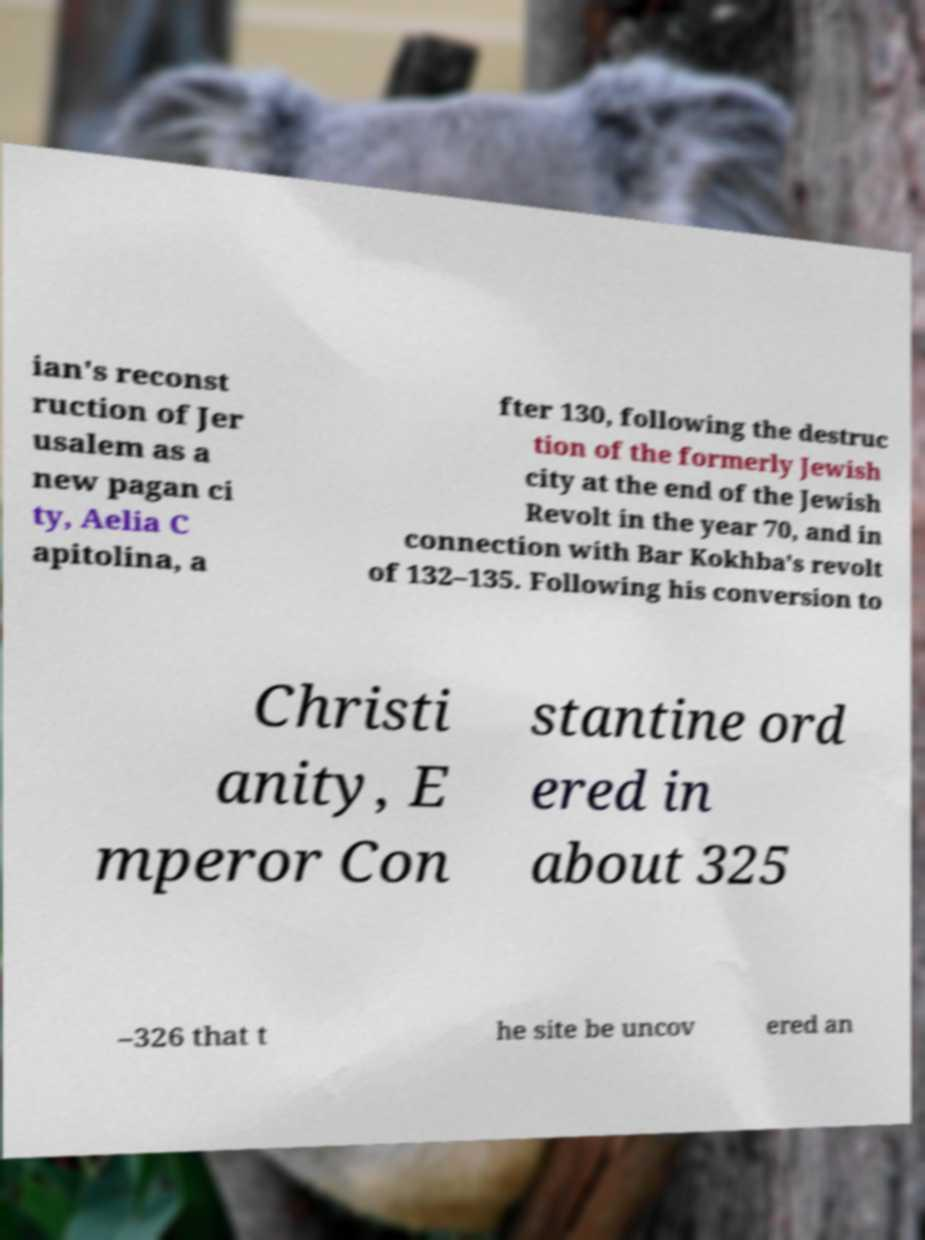Can you accurately transcribe the text from the provided image for me? ian's reconst ruction of Jer usalem as a new pagan ci ty, Aelia C apitolina, a fter 130, following the destruc tion of the formerly Jewish city at the end of the Jewish Revolt in the year 70, and in connection with Bar Kokhba's revolt of 132–135. Following his conversion to Christi anity, E mperor Con stantine ord ered in about 325 –326 that t he site be uncov ered an 